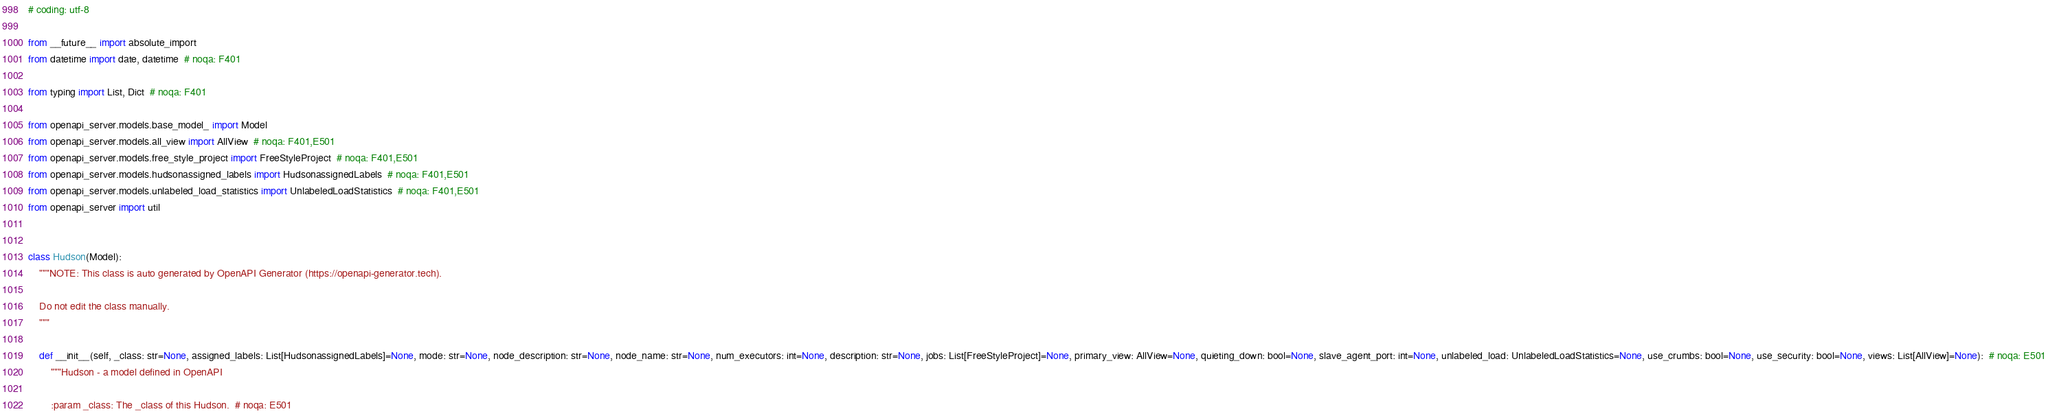<code> <loc_0><loc_0><loc_500><loc_500><_Python_># coding: utf-8

from __future__ import absolute_import
from datetime import date, datetime  # noqa: F401

from typing import List, Dict  # noqa: F401

from openapi_server.models.base_model_ import Model
from openapi_server.models.all_view import AllView  # noqa: F401,E501
from openapi_server.models.free_style_project import FreeStyleProject  # noqa: F401,E501
from openapi_server.models.hudsonassigned_labels import HudsonassignedLabels  # noqa: F401,E501
from openapi_server.models.unlabeled_load_statistics import UnlabeledLoadStatistics  # noqa: F401,E501
from openapi_server import util


class Hudson(Model):
    """NOTE: This class is auto generated by OpenAPI Generator (https://openapi-generator.tech).

    Do not edit the class manually.
    """

    def __init__(self, _class: str=None, assigned_labels: List[HudsonassignedLabels]=None, mode: str=None, node_description: str=None, node_name: str=None, num_executors: int=None, description: str=None, jobs: List[FreeStyleProject]=None, primary_view: AllView=None, quieting_down: bool=None, slave_agent_port: int=None, unlabeled_load: UnlabeledLoadStatistics=None, use_crumbs: bool=None, use_security: bool=None, views: List[AllView]=None):  # noqa: E501
        """Hudson - a model defined in OpenAPI

        :param _class: The _class of this Hudson.  # noqa: E501</code> 